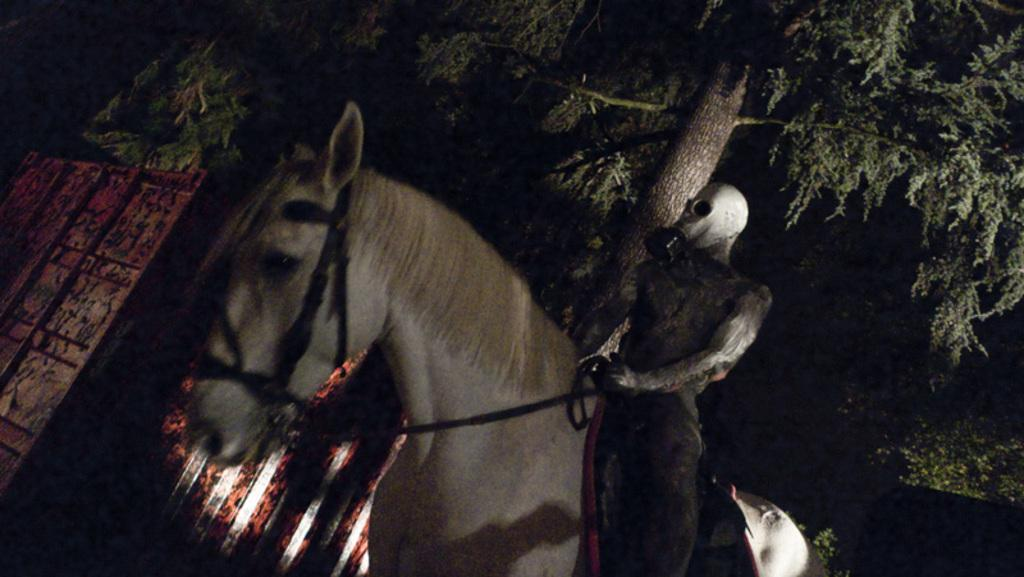What is the person in the image doing? There is a person sitting on a horse in the image. What is the person holding in their hand? The person is holding a rope in the image. What can be seen in the background of the image? There are trees visible in the background of the image. What type of marble is visible on the ground in the image? There is no marble visible on the ground in the image. What type of cable is being used by the person sitting on the horse in the image? There is no cable present in the image. 